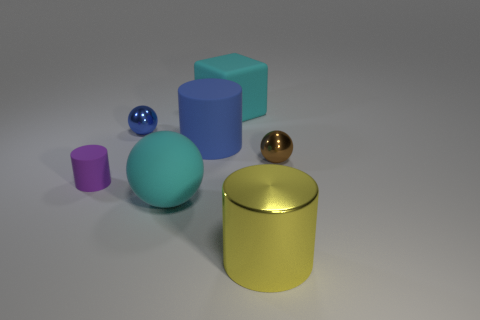Subtract all red cylinders. Subtract all red balls. How many cylinders are left? 3 Add 2 rubber cubes. How many objects exist? 9 Subtract all cubes. How many objects are left? 6 Subtract 0 purple cubes. How many objects are left? 7 Subtract all large spheres. Subtract all small red matte balls. How many objects are left? 6 Add 6 matte spheres. How many matte spheres are left? 7 Add 6 large metallic spheres. How many large metallic spheres exist? 6 